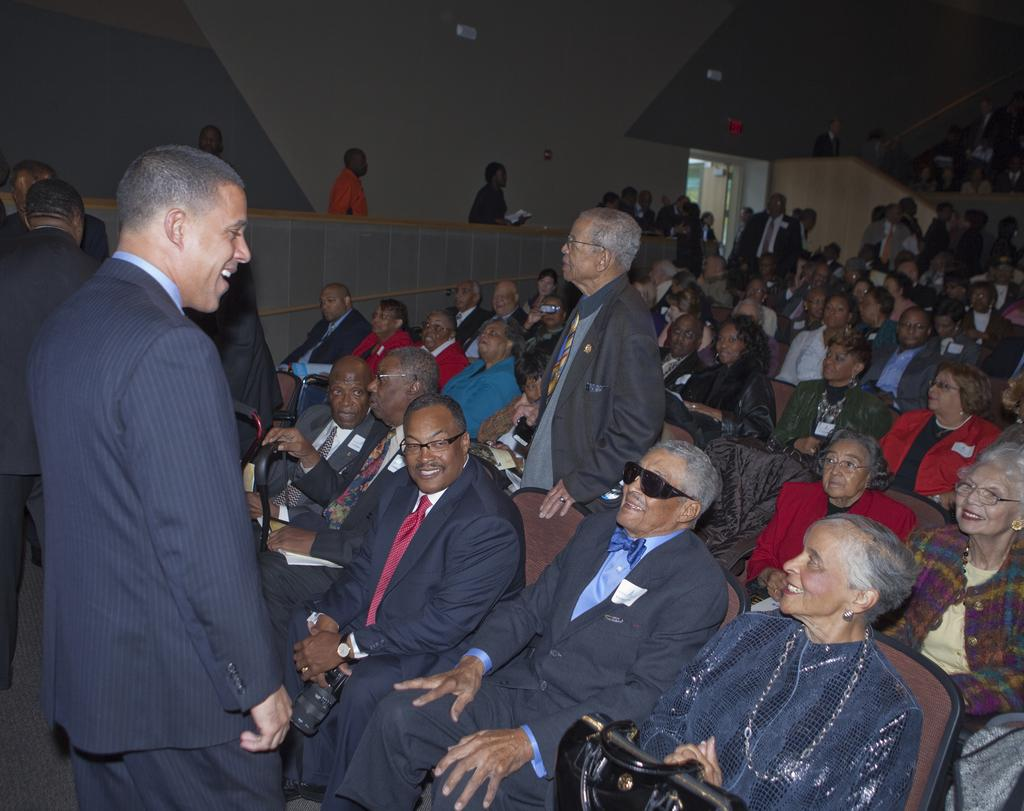What is the main subject of the image? The main subject of the image is a crowd. Can you describe any structures or objects in the image? Yes, there is a door and a wall in the image. What type of whistle can be heard coming from the crowd in the image? There is no whistle present in the image, and therefore no sound can be heard. 